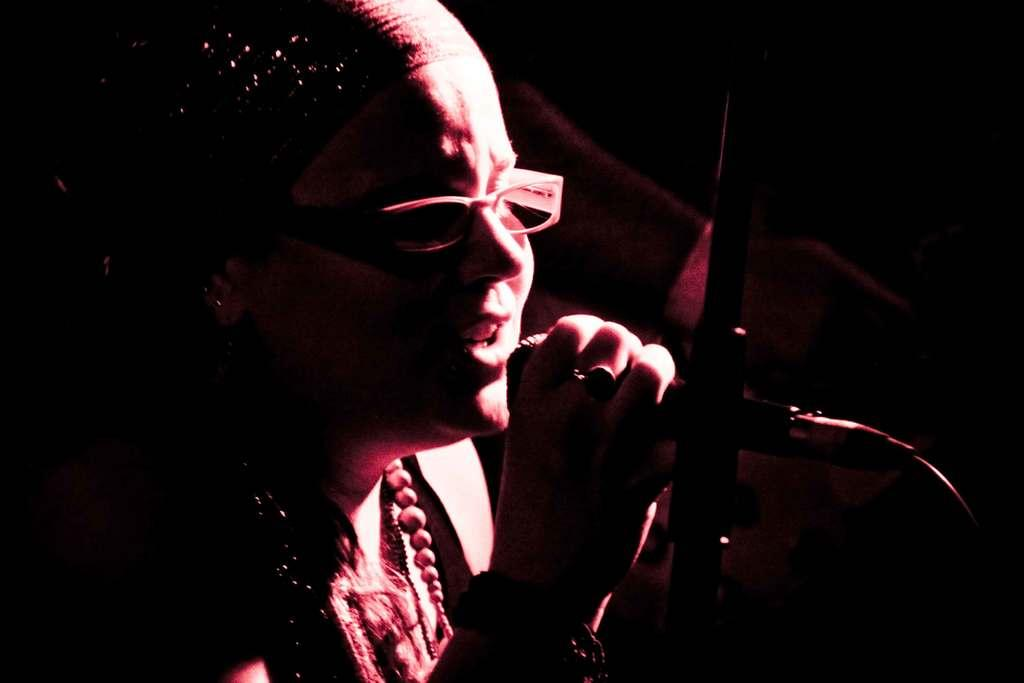What is the main subject of the image? There is a person in the image. What is the person holding in their hand? The person is holding a mic in their hand. Can you describe the object in the image? Unfortunately, the provided facts do not give any information about the object in the image. What is the color of the background in the image? The background of the image is dark. How many geese are visible in the image? There are no geese present in the image. Is the person speaking quietly in the image? The provided facts do not give any information about the person's volume or the presence of any sound. 